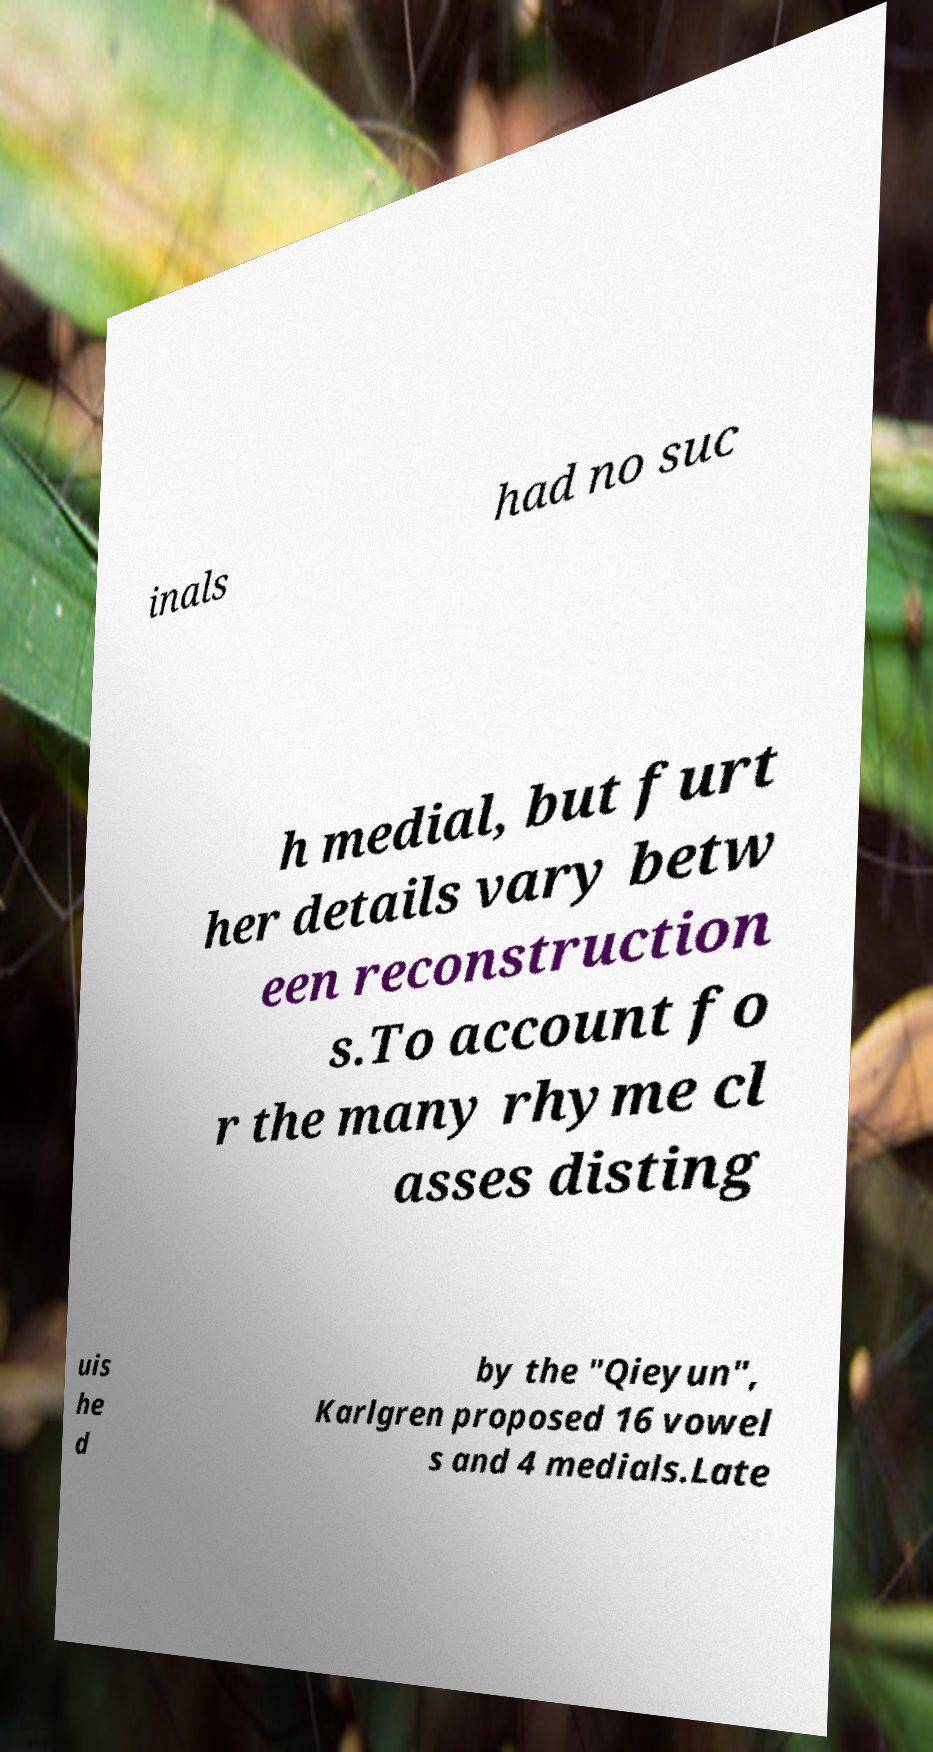Please identify and transcribe the text found in this image. inals had no suc h medial, but furt her details vary betw een reconstruction s.To account fo r the many rhyme cl asses disting uis he d by the "Qieyun", Karlgren proposed 16 vowel s and 4 medials.Late 